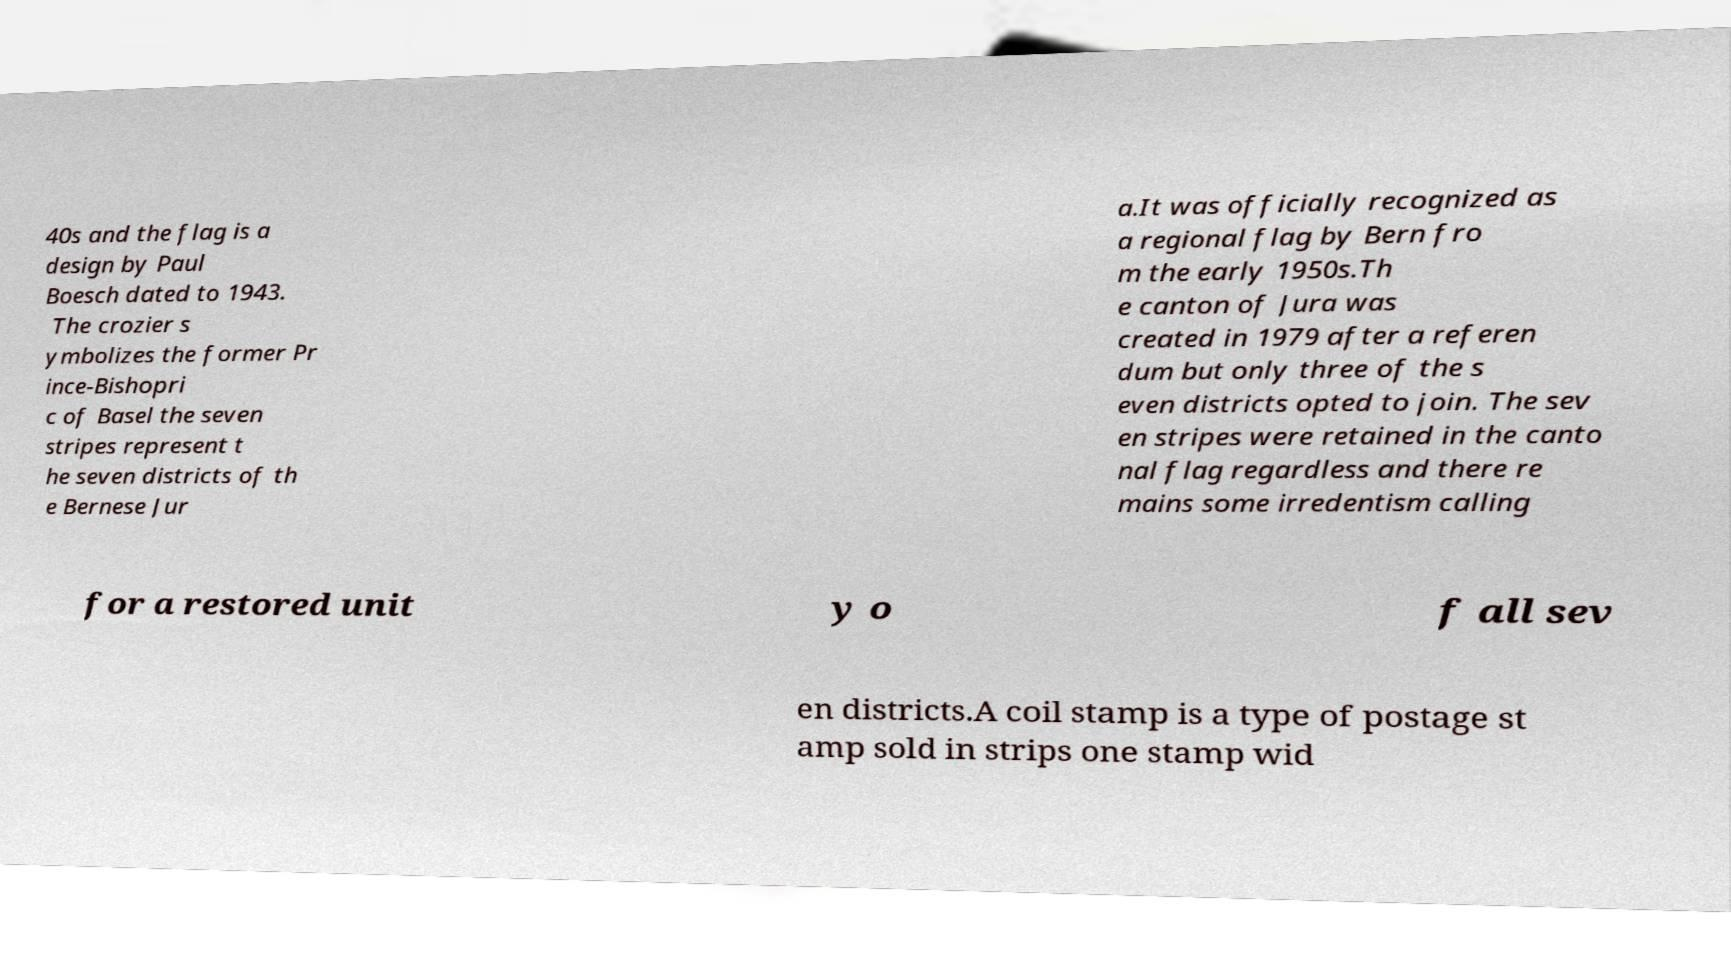I need the written content from this picture converted into text. Can you do that? 40s and the flag is a design by Paul Boesch dated to 1943. The crozier s ymbolizes the former Pr ince-Bishopri c of Basel the seven stripes represent t he seven districts of th e Bernese Jur a.It was officially recognized as a regional flag by Bern fro m the early 1950s.Th e canton of Jura was created in 1979 after a referen dum but only three of the s even districts opted to join. The sev en stripes were retained in the canto nal flag regardless and there re mains some irredentism calling for a restored unit y o f all sev en districts.A coil stamp is a type of postage st amp sold in strips one stamp wid 